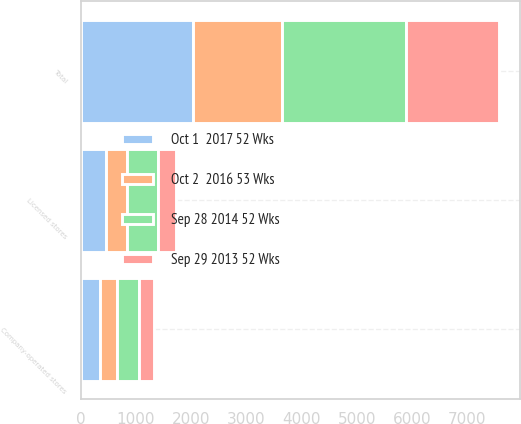<chart> <loc_0><loc_0><loc_500><loc_500><stacked_bar_chart><ecel><fcel>Company-operated stores<fcel>Licensed stores<fcel>Total<nl><fcel>Sep 28 2014 52 Wks<fcel>394<fcel>558<fcel>2254<nl><fcel>Oct 1  2017 52 Wks<fcel>348<fcel>456<fcel>2042<nl><fcel>Sep 29 2013 52 Wks<fcel>276<fcel>336<fcel>1677<nl><fcel>Oct 2  2016 53 Wks<fcel>317<fcel>381<fcel>1599<nl></chart> 